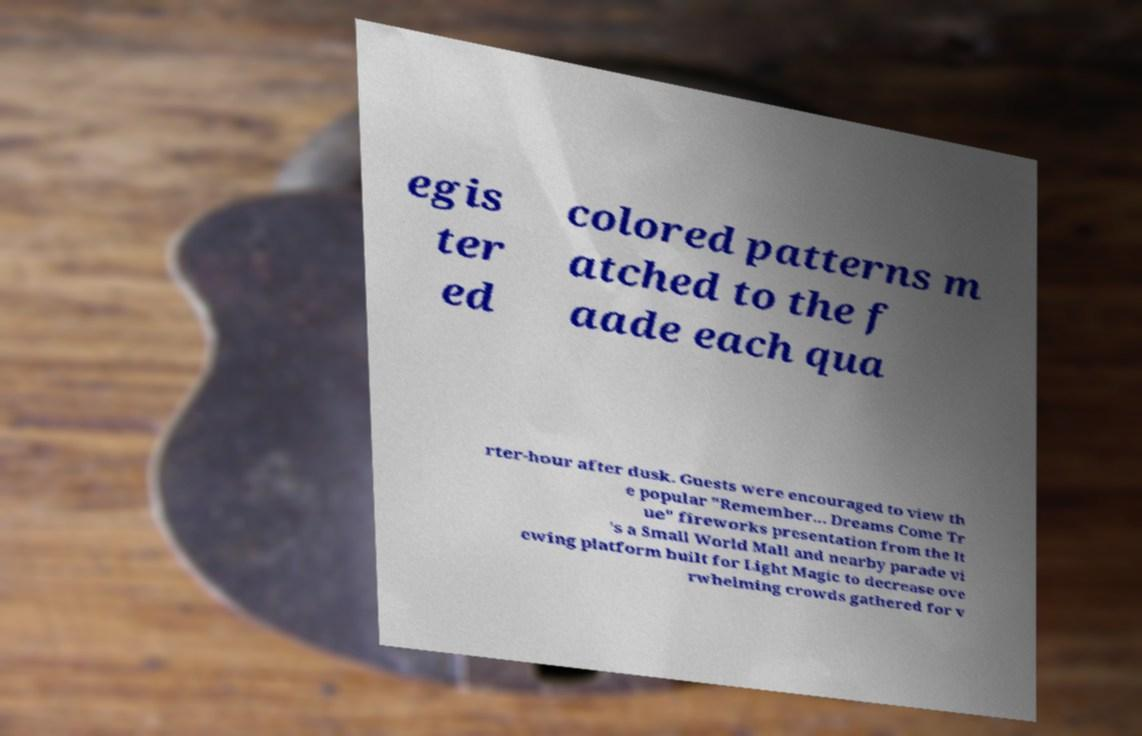Please identify and transcribe the text found in this image. egis ter ed colored patterns m atched to the f aade each qua rter-hour after dusk. Guests were encouraged to view th e popular "Remember... Dreams Come Tr ue" fireworks presentation from the It 's a Small World Mall and nearby parade vi ewing platform built for Light Magic to decrease ove rwhelming crowds gathered for v 